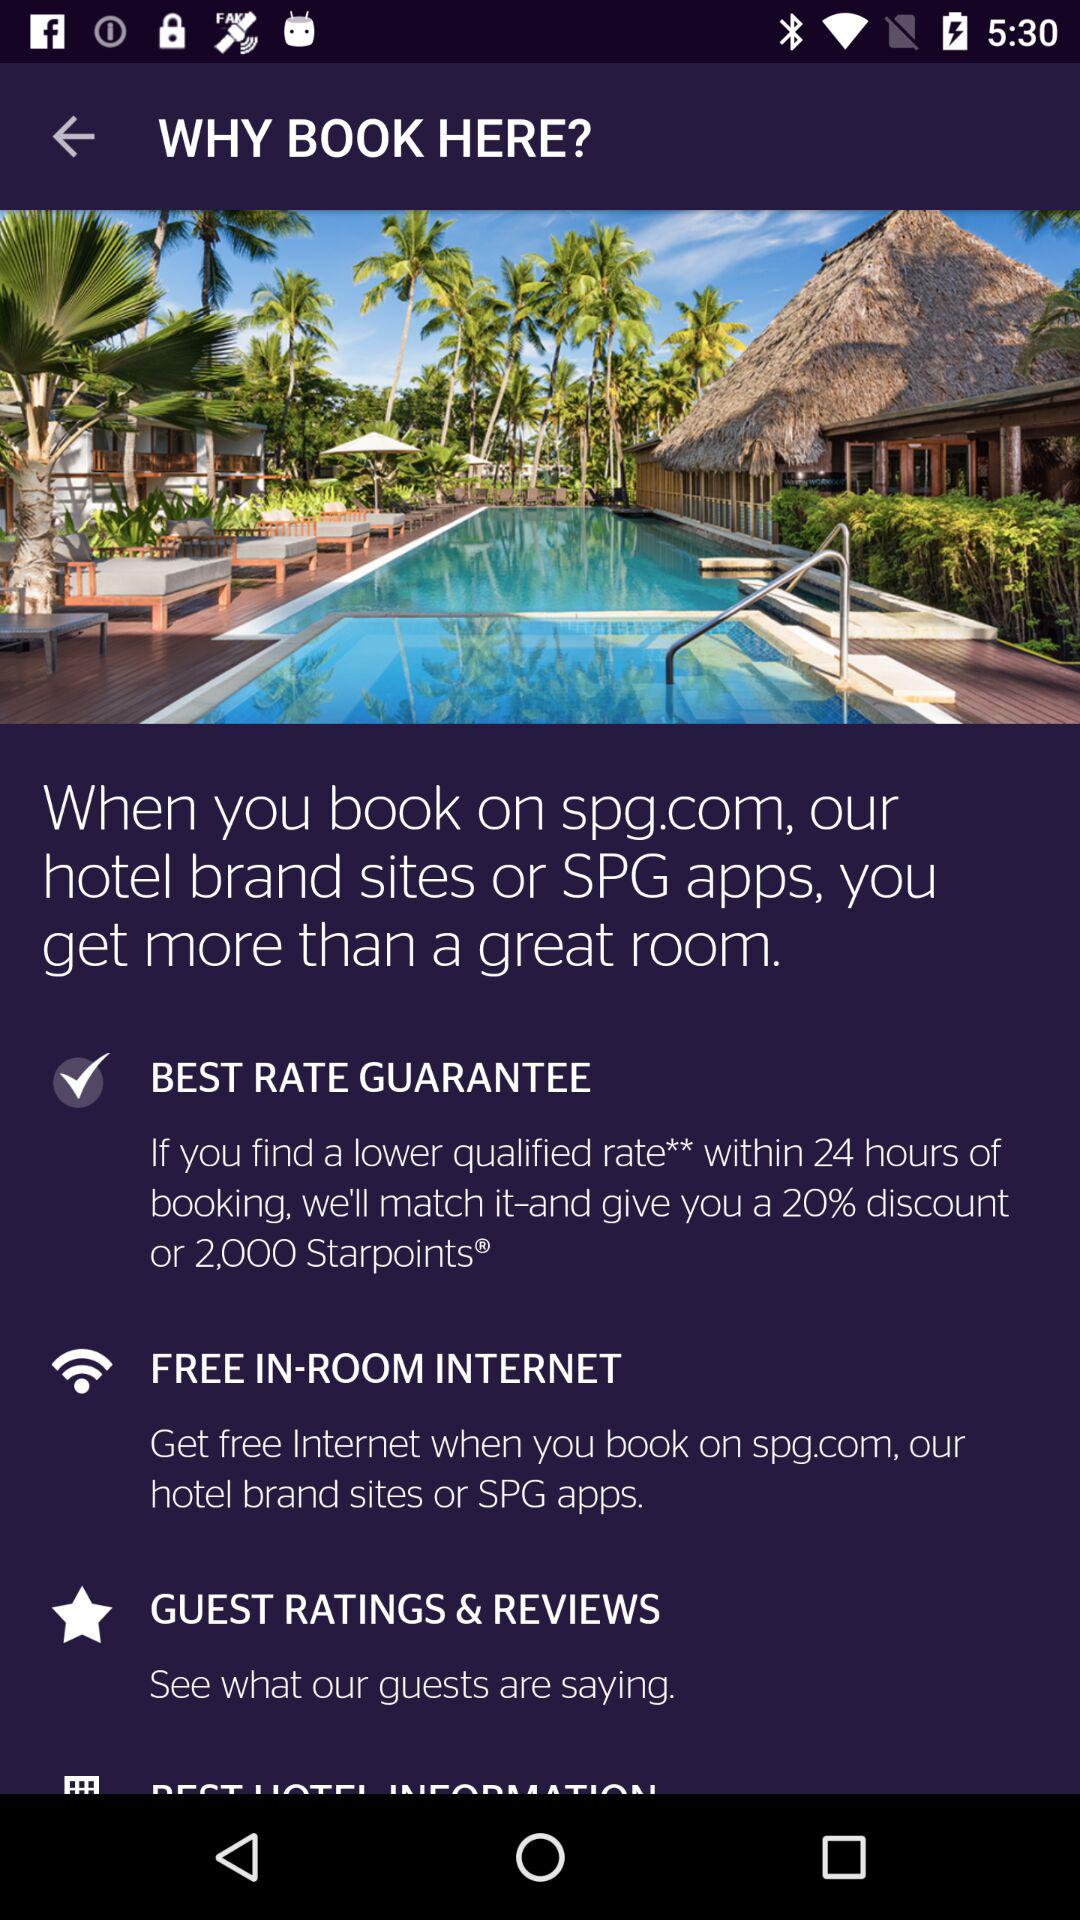What is the booking website name? The booking website name is spg.com. 